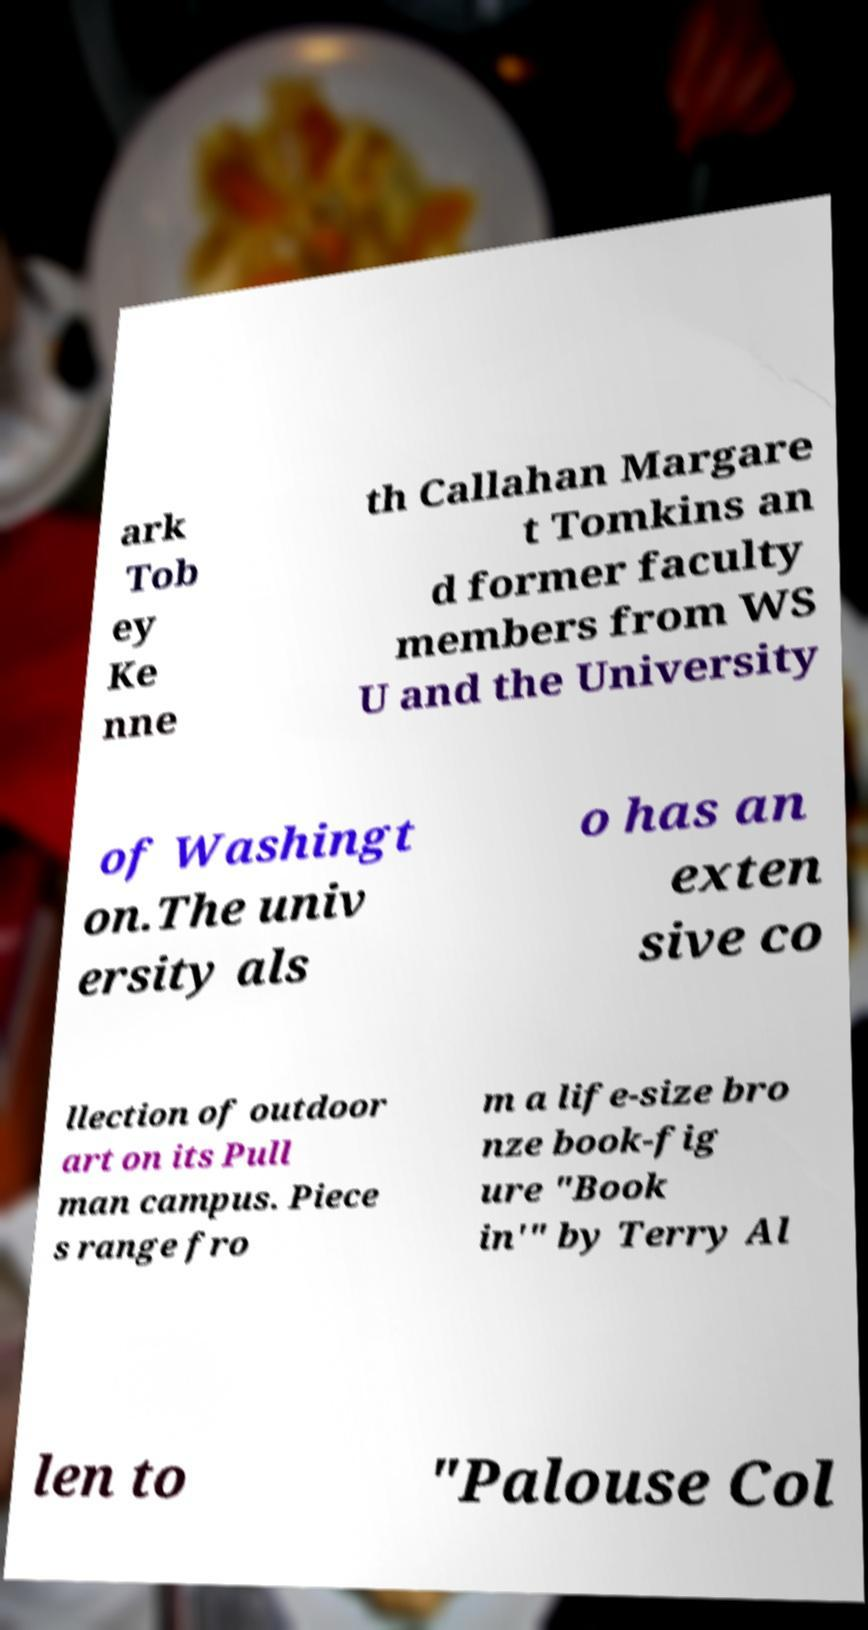What messages or text are displayed in this image? I need them in a readable, typed format. ark Tob ey Ke nne th Callahan Margare t Tomkins an d former faculty members from WS U and the University of Washingt on.The univ ersity als o has an exten sive co llection of outdoor art on its Pull man campus. Piece s range fro m a life-size bro nze book-fig ure "Book in'" by Terry Al len to "Palouse Col 